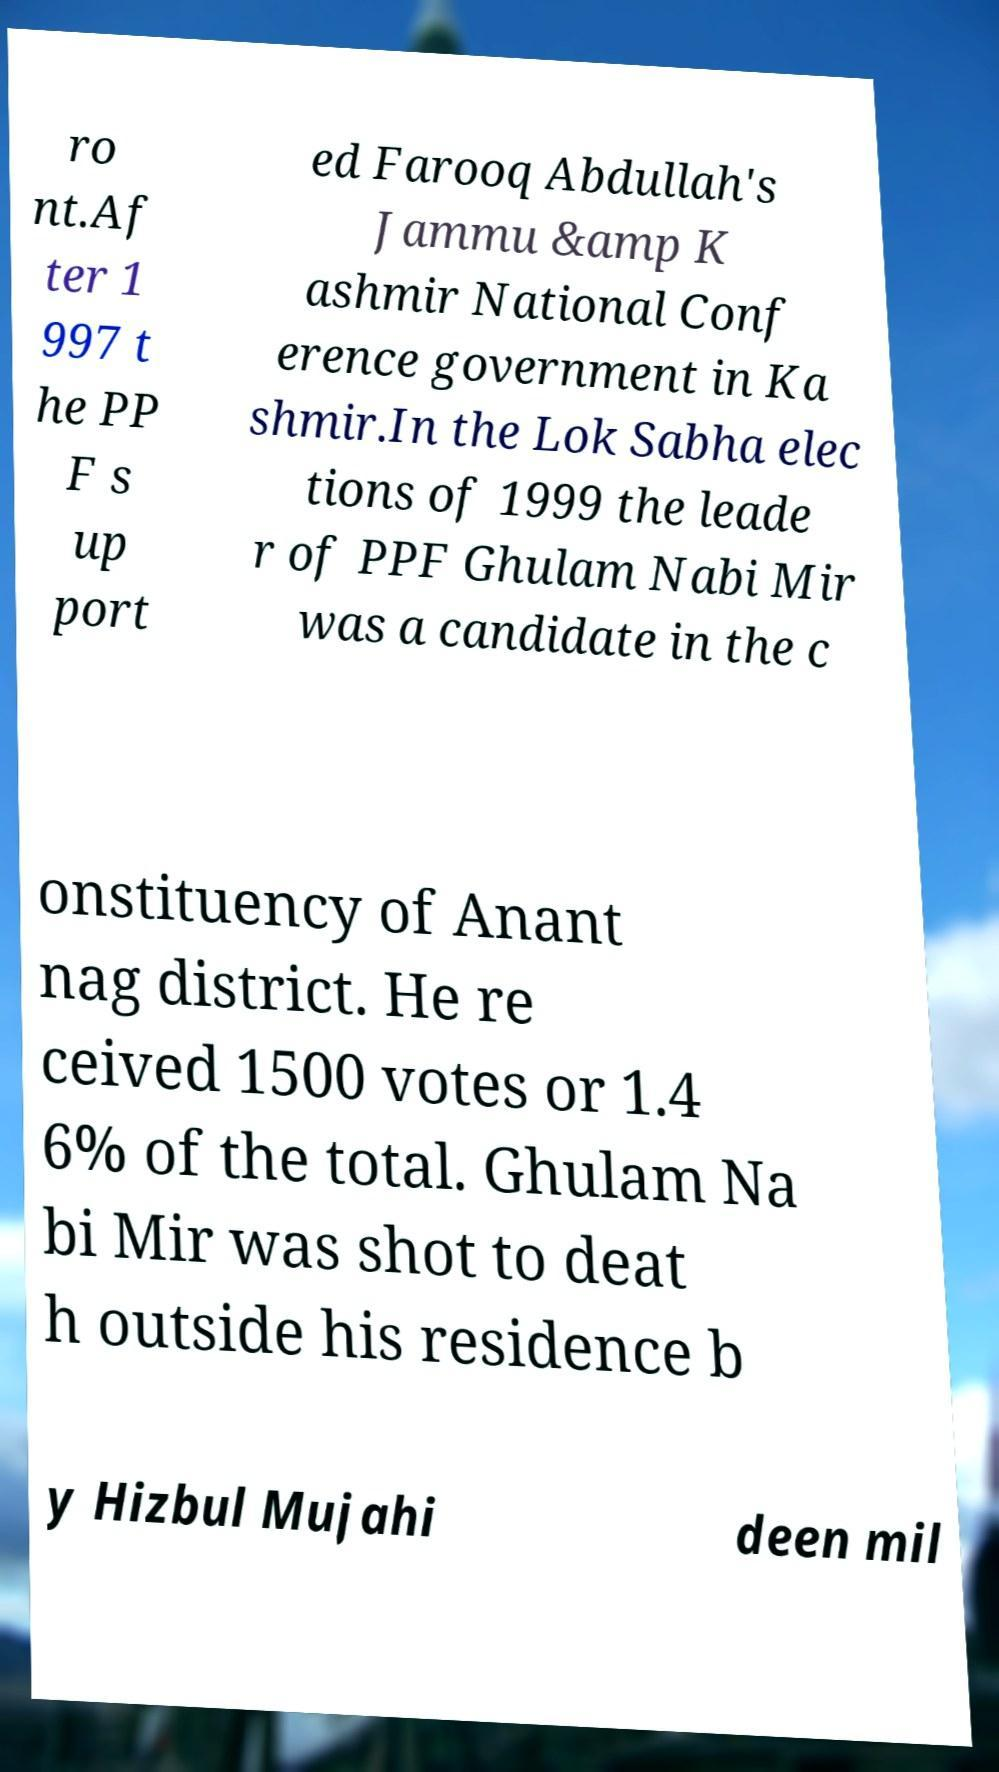What messages or text are displayed in this image? I need them in a readable, typed format. ro nt.Af ter 1 997 t he PP F s up port ed Farooq Abdullah's Jammu &amp K ashmir National Conf erence government in Ka shmir.In the Lok Sabha elec tions of 1999 the leade r of PPF Ghulam Nabi Mir was a candidate in the c onstituency of Anant nag district. He re ceived 1500 votes or 1.4 6% of the total. Ghulam Na bi Mir was shot to deat h outside his residence b y Hizbul Mujahi deen mil 